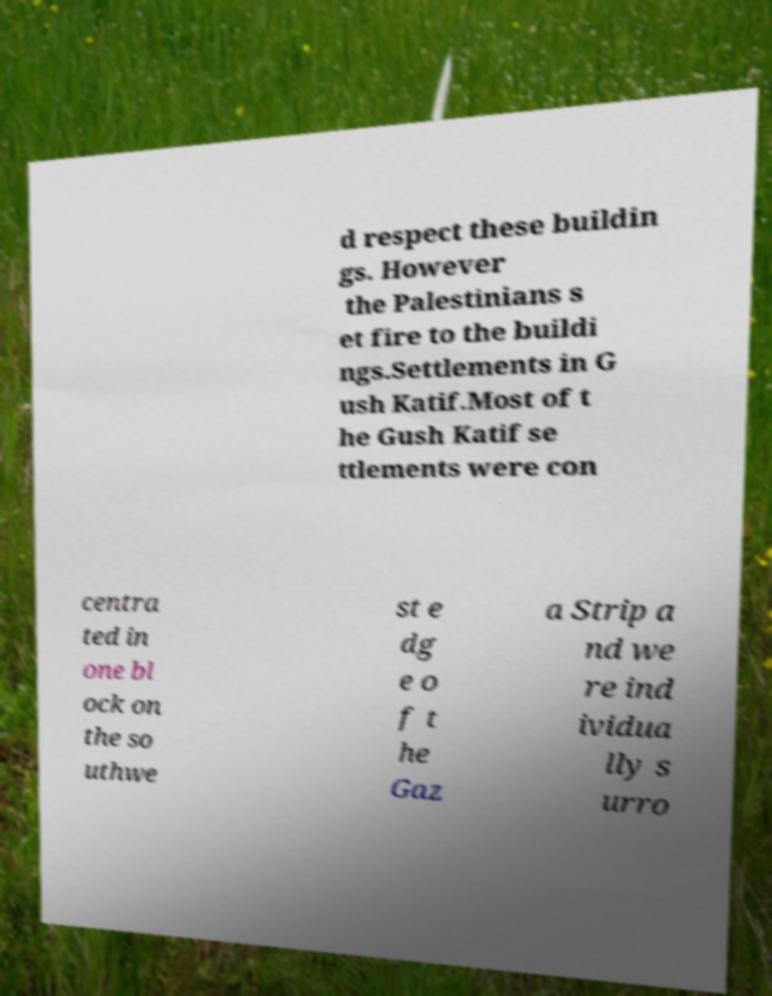Please identify and transcribe the text found in this image. d respect these buildin gs. However the Palestinians s et fire to the buildi ngs.Settlements in G ush Katif.Most of t he Gush Katif se ttlements were con centra ted in one bl ock on the so uthwe st e dg e o f t he Gaz a Strip a nd we re ind ividua lly s urro 